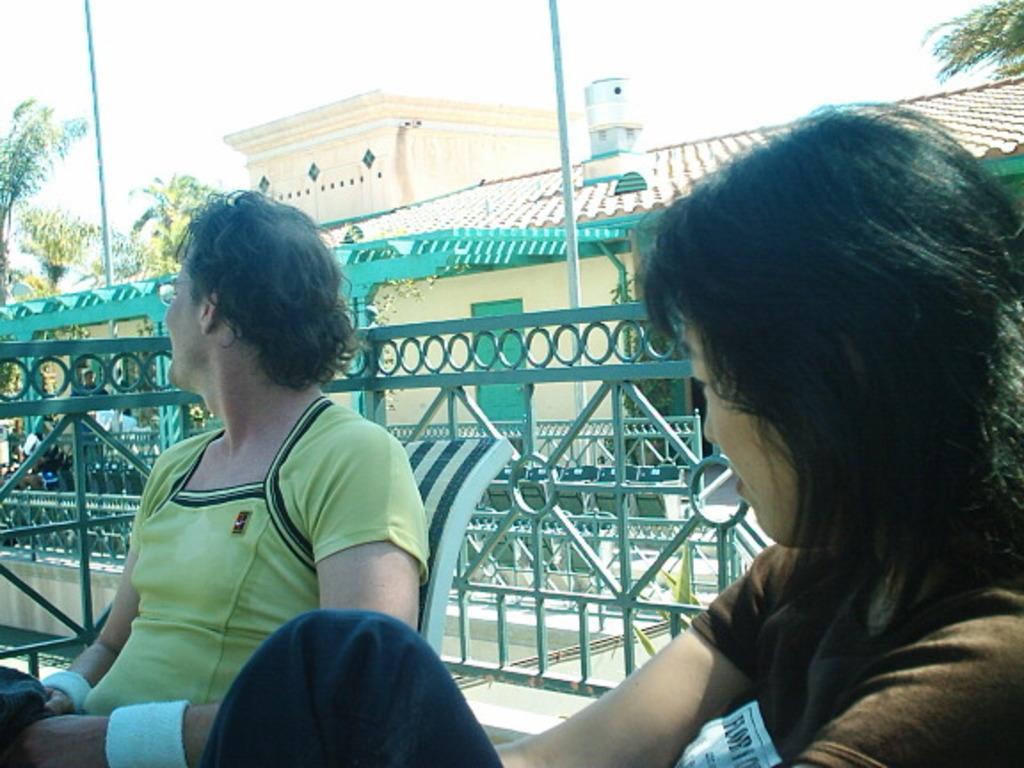Describe this image in one or two sentences. In this image, we can see two persons sitting on the chairs, there is a fencing and in the background there is a house and there are some green color trees, at the top there is a sky. 